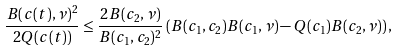<formula> <loc_0><loc_0><loc_500><loc_500>\frac { B ( c ( t ) , \nu ) ^ { 2 } } { 2 Q ( c ( t ) ) } \leq \frac { 2 B ( c _ { 2 } , \nu ) } { B ( c _ { 1 } , c _ { 2 } ) ^ { 2 } } \left ( B ( c _ { 1 } , c _ { 2 } ) B ( c _ { 1 } , \nu ) - Q ( c _ { 1 } ) B ( c _ { 2 } , \nu ) \right ) ,</formula> 